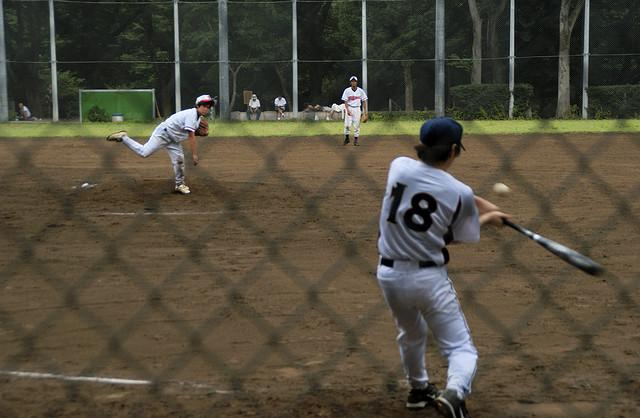Who will next cause the balls direction to change? Please explain your reasoning. 18. The batter is wearing number 18 and he will hit the ball next. 